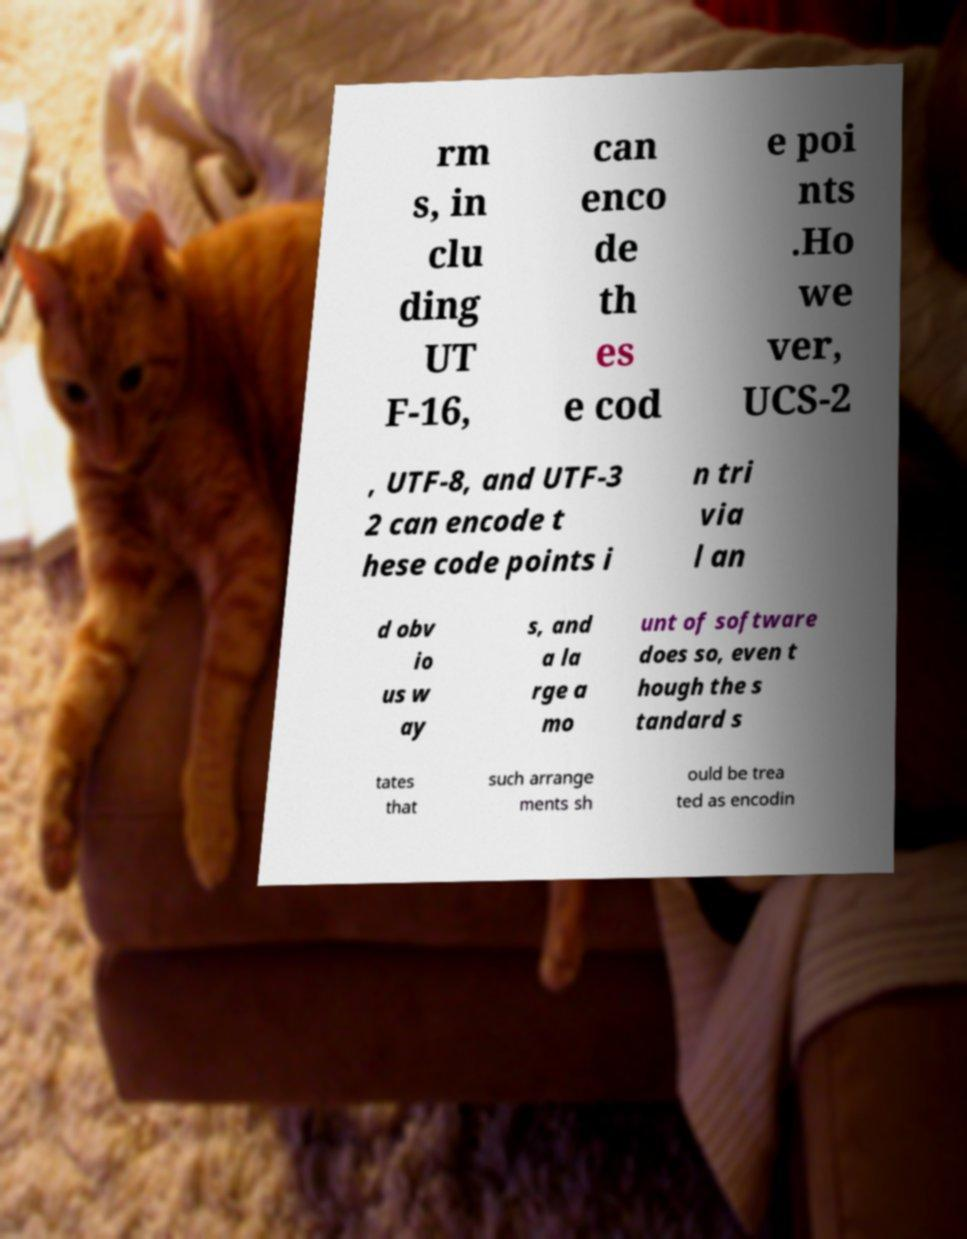There's text embedded in this image that I need extracted. Can you transcribe it verbatim? rm s, in clu ding UT F-16, can enco de th es e cod e poi nts .Ho we ver, UCS-2 , UTF-8, and UTF-3 2 can encode t hese code points i n tri via l an d obv io us w ay s, and a la rge a mo unt of software does so, even t hough the s tandard s tates that such arrange ments sh ould be trea ted as encodin 